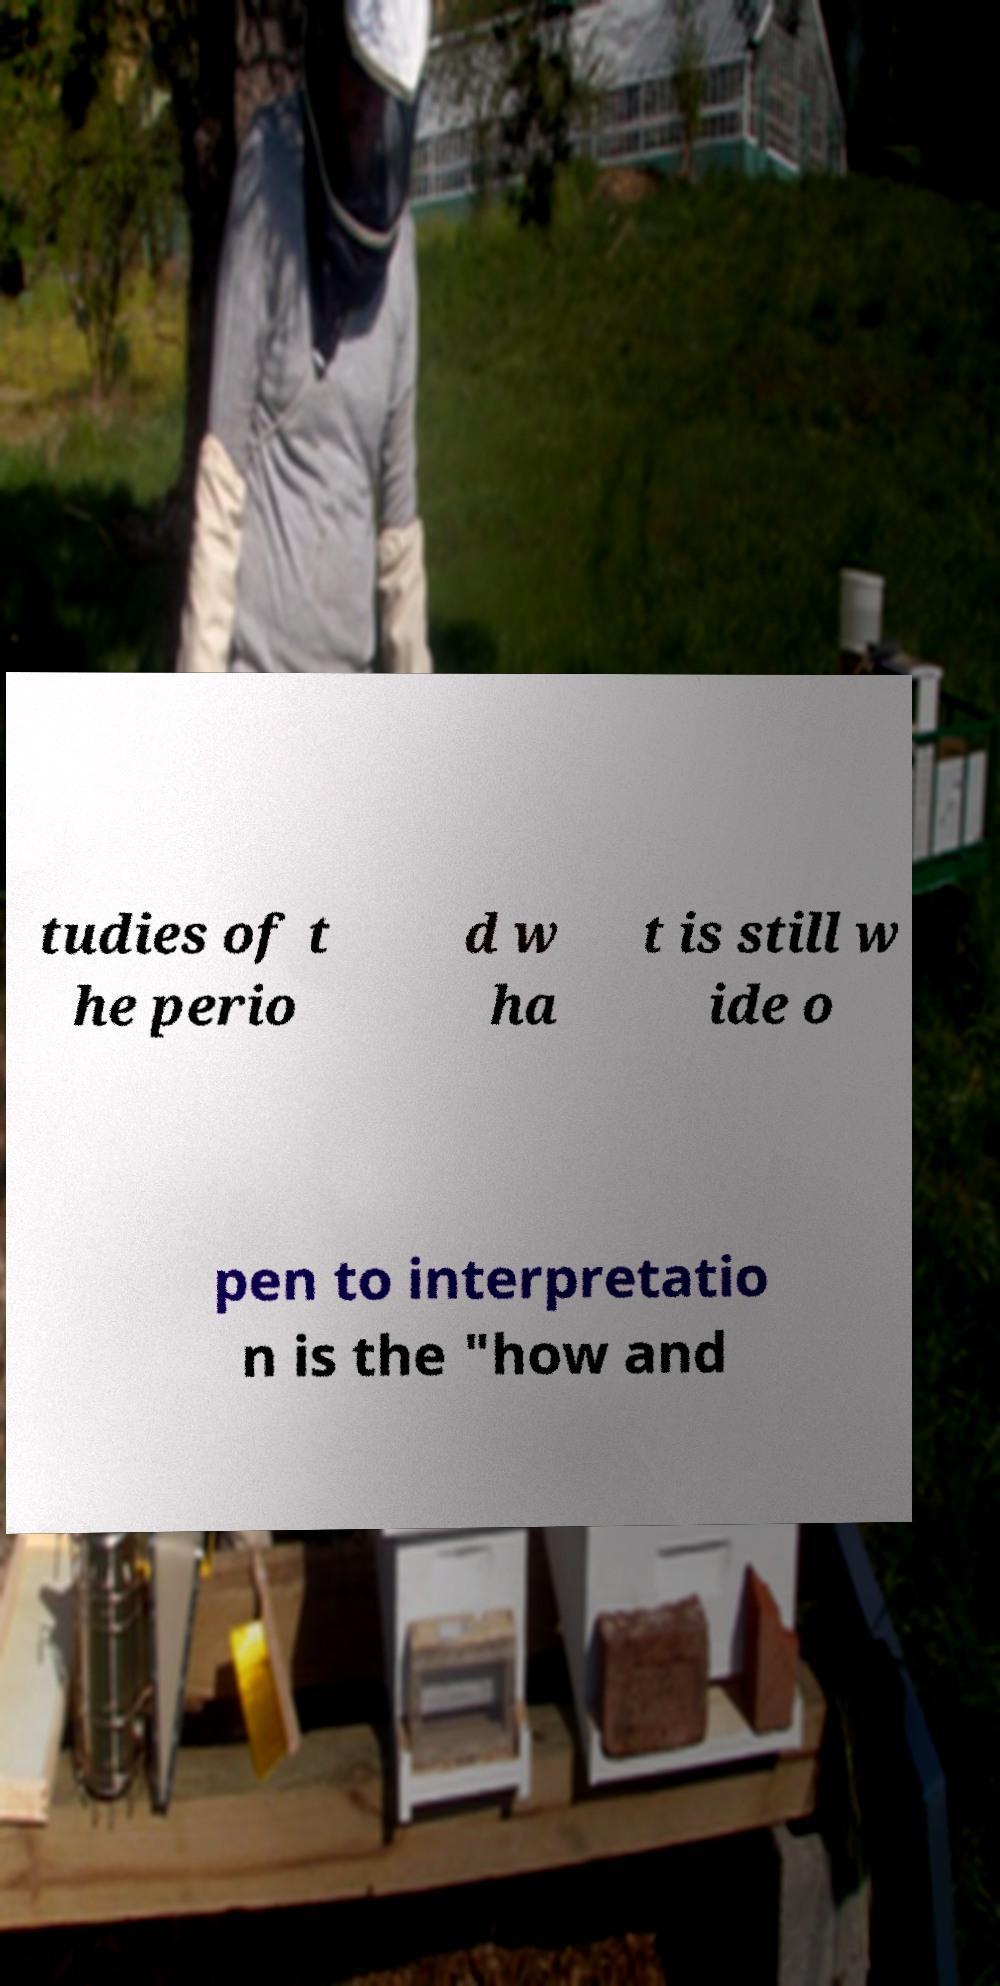What messages or text are displayed in this image? I need them in a readable, typed format. tudies of t he perio d w ha t is still w ide o pen to interpretatio n is the "how and 